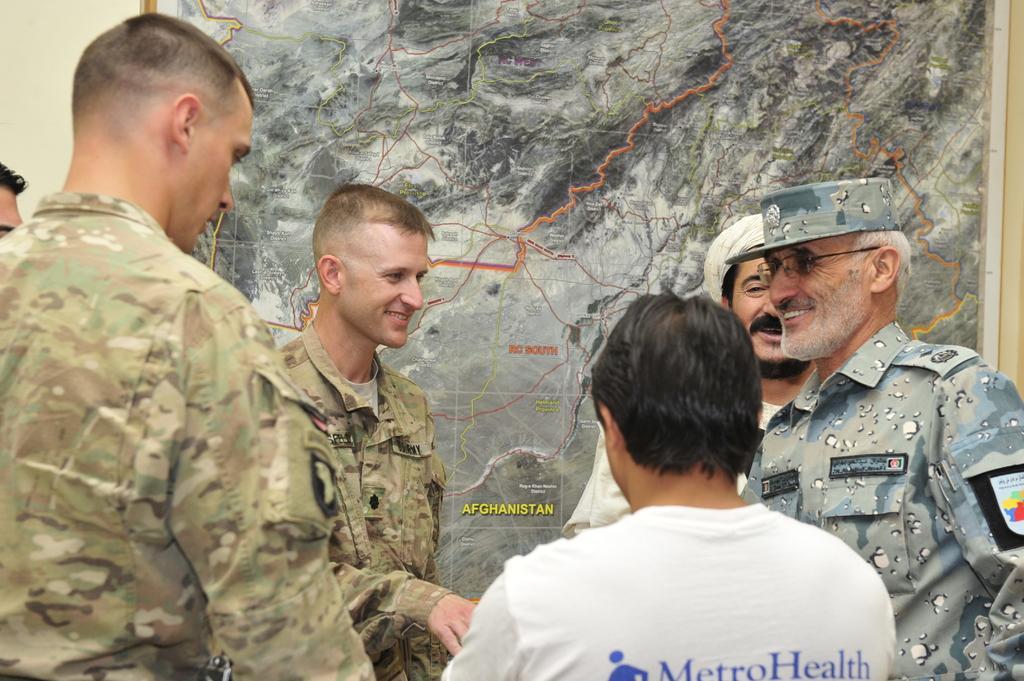Please provide a concise description of this image. There are some people standing. Person on the right is wearing specs and cap. In the background there is a wall. On the wall there is a map. 